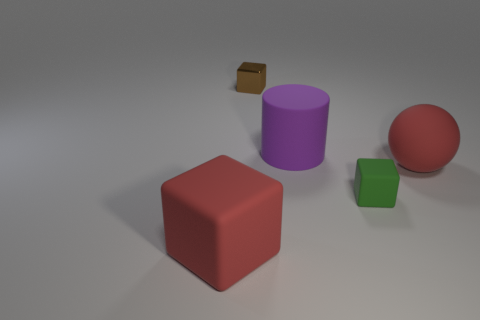What color is the rubber ball? red 